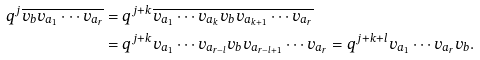Convert formula to latex. <formula><loc_0><loc_0><loc_500><loc_500>q ^ { j } \overline { v _ { b } v _ { a _ { 1 } } \cdots v _ { a _ { r } } } & = q ^ { j + k } \overline { v _ { a _ { 1 } } \cdots v _ { a _ { k } } v _ { b } v _ { a _ { k + 1 } } \cdots v _ { a _ { r } } } \\ & = q ^ { j + k } v _ { a _ { 1 } } \cdots v _ { a _ { r - l } } v _ { b } v _ { a _ { r - l + 1 } } \cdots v _ { a _ { r } } = q ^ { j + k + l } v _ { a _ { 1 } } \cdots v _ { a _ { r } } v _ { b } .</formula> 